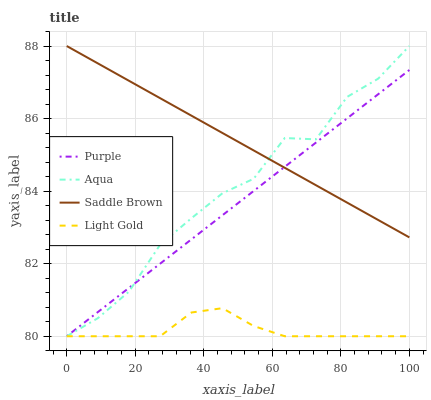Does Light Gold have the minimum area under the curve?
Answer yes or no. Yes. Does Saddle Brown have the maximum area under the curve?
Answer yes or no. Yes. Does Aqua have the minimum area under the curve?
Answer yes or no. No. Does Aqua have the maximum area under the curve?
Answer yes or no. No. Is Purple the smoothest?
Answer yes or no. Yes. Is Aqua the roughest?
Answer yes or no. Yes. Is Light Gold the smoothest?
Answer yes or no. No. Is Light Gold the roughest?
Answer yes or no. No. Does Purple have the lowest value?
Answer yes or no. Yes. Does Saddle Brown have the lowest value?
Answer yes or no. No. Does Saddle Brown have the highest value?
Answer yes or no. Yes. Does Light Gold have the highest value?
Answer yes or no. No. Is Light Gold less than Saddle Brown?
Answer yes or no. Yes. Is Saddle Brown greater than Light Gold?
Answer yes or no. Yes. Does Saddle Brown intersect Purple?
Answer yes or no. Yes. Is Saddle Brown less than Purple?
Answer yes or no. No. Is Saddle Brown greater than Purple?
Answer yes or no. No. Does Light Gold intersect Saddle Brown?
Answer yes or no. No. 